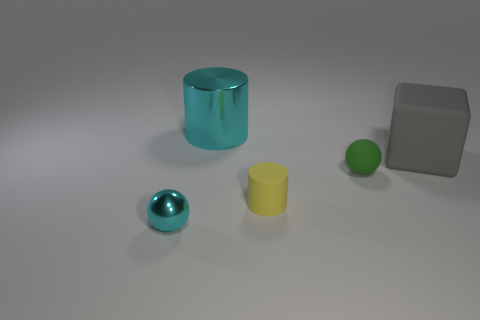There is a tiny yellow thing that is made of the same material as the large gray cube; what shape is it?
Make the answer very short. Cylinder. Is there any other thing of the same color as the big metal object?
Make the answer very short. Yes. Is the number of cylinders that are to the right of the large shiny cylinder greater than the number of tiny metallic objects?
Your answer should be compact. No. What material is the tiny cylinder?
Your answer should be very brief. Rubber. How many things are the same size as the cyan sphere?
Give a very brief answer. 2. Is the number of tiny yellow things that are to the left of the tiny yellow matte cylinder the same as the number of metallic cylinders that are in front of the tiny green rubber sphere?
Keep it short and to the point. Yes. Is the small green thing made of the same material as the tiny yellow cylinder?
Your response must be concise. Yes. Are there any tiny yellow objects that are in front of the tiny thing that is to the right of the small yellow thing?
Your answer should be very brief. Yes. Is there another metallic object that has the same shape as the tiny cyan shiny thing?
Make the answer very short. No. Does the large matte block have the same color as the shiny sphere?
Your answer should be compact. No. 